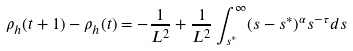Convert formula to latex. <formula><loc_0><loc_0><loc_500><loc_500>\rho _ { h } ( t + 1 ) - \rho _ { h } ( t ) = - \frac { 1 } { L ^ { 2 } } + \frac { 1 } { L ^ { 2 } } \int _ { s ^ { * } } ^ { \infty } ( s - s ^ { * } ) ^ { \alpha } s ^ { - \tau } d s</formula> 